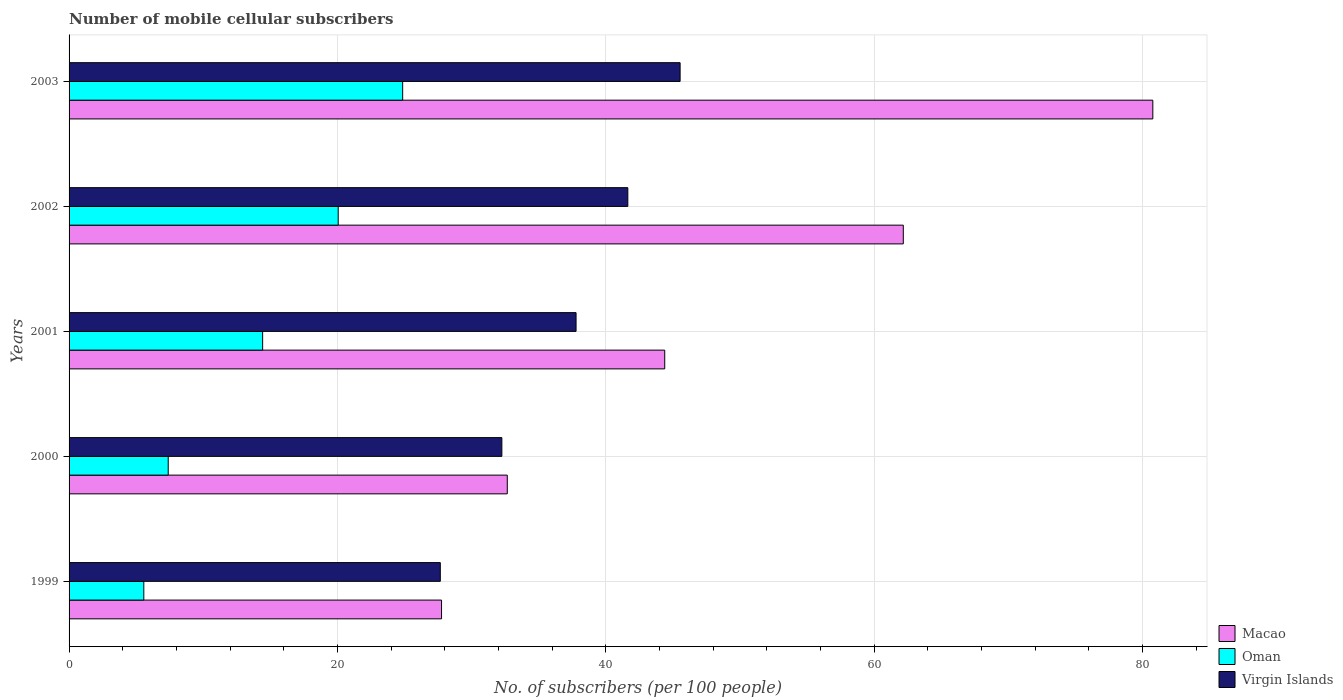Are the number of bars on each tick of the Y-axis equal?
Offer a terse response. Yes. How many bars are there on the 1st tick from the top?
Provide a succinct answer. 3. In how many cases, is the number of bars for a given year not equal to the number of legend labels?
Ensure brevity in your answer.  0. What is the number of mobile cellular subscribers in Virgin Islands in 2001?
Provide a succinct answer. 37.78. Across all years, what is the maximum number of mobile cellular subscribers in Oman?
Your answer should be compact. 24.86. Across all years, what is the minimum number of mobile cellular subscribers in Virgin Islands?
Your answer should be very brief. 27.67. In which year was the number of mobile cellular subscribers in Macao minimum?
Your answer should be compact. 1999. What is the total number of mobile cellular subscribers in Oman in the graph?
Provide a succinct answer. 72.3. What is the difference between the number of mobile cellular subscribers in Oman in 1999 and that in 2003?
Make the answer very short. -19.29. What is the difference between the number of mobile cellular subscribers in Macao in 1999 and the number of mobile cellular subscribers in Oman in 2003?
Offer a very short reply. 2.9. What is the average number of mobile cellular subscribers in Virgin Islands per year?
Keep it short and to the point. 36.98. In the year 2003, what is the difference between the number of mobile cellular subscribers in Virgin Islands and number of mobile cellular subscribers in Macao?
Provide a short and direct response. -35.23. In how many years, is the number of mobile cellular subscribers in Virgin Islands greater than 72 ?
Make the answer very short. 0. What is the ratio of the number of mobile cellular subscribers in Macao in 2001 to that in 2002?
Keep it short and to the point. 0.71. Is the difference between the number of mobile cellular subscribers in Virgin Islands in 1999 and 2003 greater than the difference between the number of mobile cellular subscribers in Macao in 1999 and 2003?
Your answer should be compact. Yes. What is the difference between the highest and the second highest number of mobile cellular subscribers in Oman?
Your response must be concise. 4.81. What is the difference between the highest and the lowest number of mobile cellular subscribers in Oman?
Provide a succinct answer. 19.29. What does the 1st bar from the top in 2002 represents?
Offer a terse response. Virgin Islands. What does the 2nd bar from the bottom in 2000 represents?
Offer a very short reply. Oman. Is it the case that in every year, the sum of the number of mobile cellular subscribers in Oman and number of mobile cellular subscribers in Virgin Islands is greater than the number of mobile cellular subscribers in Macao?
Ensure brevity in your answer.  No. Are all the bars in the graph horizontal?
Make the answer very short. Yes. How many years are there in the graph?
Provide a short and direct response. 5. What is the difference between two consecutive major ticks on the X-axis?
Your response must be concise. 20. Does the graph contain any zero values?
Keep it short and to the point. No. Where does the legend appear in the graph?
Provide a short and direct response. Bottom right. How are the legend labels stacked?
Make the answer very short. Vertical. What is the title of the graph?
Offer a terse response. Number of mobile cellular subscribers. Does "Israel" appear as one of the legend labels in the graph?
Provide a succinct answer. No. What is the label or title of the X-axis?
Make the answer very short. No. of subscribers (per 100 people). What is the label or title of the Y-axis?
Keep it short and to the point. Years. What is the No. of subscribers (per 100 people) of Macao in 1999?
Ensure brevity in your answer.  27.76. What is the No. of subscribers (per 100 people) in Oman in 1999?
Provide a short and direct response. 5.57. What is the No. of subscribers (per 100 people) in Virgin Islands in 1999?
Offer a terse response. 27.67. What is the No. of subscribers (per 100 people) of Macao in 2000?
Keep it short and to the point. 32.66. What is the No. of subscribers (per 100 people) in Oman in 2000?
Give a very brief answer. 7.39. What is the No. of subscribers (per 100 people) of Virgin Islands in 2000?
Offer a terse response. 32.25. What is the No. of subscribers (per 100 people) in Macao in 2001?
Offer a terse response. 44.39. What is the No. of subscribers (per 100 people) of Oman in 2001?
Offer a terse response. 14.43. What is the No. of subscribers (per 100 people) in Virgin Islands in 2001?
Your answer should be compact. 37.78. What is the No. of subscribers (per 100 people) in Macao in 2002?
Make the answer very short. 62.17. What is the No. of subscribers (per 100 people) of Oman in 2002?
Give a very brief answer. 20.06. What is the No. of subscribers (per 100 people) in Virgin Islands in 2002?
Offer a very short reply. 41.64. What is the No. of subscribers (per 100 people) in Macao in 2003?
Provide a short and direct response. 80.77. What is the No. of subscribers (per 100 people) in Oman in 2003?
Ensure brevity in your answer.  24.86. What is the No. of subscribers (per 100 people) in Virgin Islands in 2003?
Make the answer very short. 45.54. Across all years, what is the maximum No. of subscribers (per 100 people) of Macao?
Offer a very short reply. 80.77. Across all years, what is the maximum No. of subscribers (per 100 people) of Oman?
Your answer should be very brief. 24.86. Across all years, what is the maximum No. of subscribers (per 100 people) of Virgin Islands?
Provide a succinct answer. 45.54. Across all years, what is the minimum No. of subscribers (per 100 people) of Macao?
Make the answer very short. 27.76. Across all years, what is the minimum No. of subscribers (per 100 people) in Oman?
Offer a terse response. 5.57. Across all years, what is the minimum No. of subscribers (per 100 people) of Virgin Islands?
Keep it short and to the point. 27.67. What is the total No. of subscribers (per 100 people) in Macao in the graph?
Your answer should be compact. 247.75. What is the total No. of subscribers (per 100 people) of Oman in the graph?
Provide a short and direct response. 72.3. What is the total No. of subscribers (per 100 people) of Virgin Islands in the graph?
Ensure brevity in your answer.  184.89. What is the difference between the No. of subscribers (per 100 people) in Macao in 1999 and that in 2000?
Your response must be concise. -4.9. What is the difference between the No. of subscribers (per 100 people) of Oman in 1999 and that in 2000?
Keep it short and to the point. -1.82. What is the difference between the No. of subscribers (per 100 people) of Virgin Islands in 1999 and that in 2000?
Keep it short and to the point. -4.59. What is the difference between the No. of subscribers (per 100 people) of Macao in 1999 and that in 2001?
Keep it short and to the point. -16.63. What is the difference between the No. of subscribers (per 100 people) in Oman in 1999 and that in 2001?
Offer a very short reply. -8.86. What is the difference between the No. of subscribers (per 100 people) of Virgin Islands in 1999 and that in 2001?
Your response must be concise. -10.12. What is the difference between the No. of subscribers (per 100 people) of Macao in 1999 and that in 2002?
Give a very brief answer. -34.41. What is the difference between the No. of subscribers (per 100 people) of Oman in 1999 and that in 2002?
Provide a succinct answer. -14.49. What is the difference between the No. of subscribers (per 100 people) of Virgin Islands in 1999 and that in 2002?
Your answer should be very brief. -13.98. What is the difference between the No. of subscribers (per 100 people) in Macao in 1999 and that in 2003?
Provide a succinct answer. -53.01. What is the difference between the No. of subscribers (per 100 people) in Oman in 1999 and that in 2003?
Your response must be concise. -19.29. What is the difference between the No. of subscribers (per 100 people) in Virgin Islands in 1999 and that in 2003?
Offer a very short reply. -17.87. What is the difference between the No. of subscribers (per 100 people) in Macao in 2000 and that in 2001?
Make the answer very short. -11.73. What is the difference between the No. of subscribers (per 100 people) in Oman in 2000 and that in 2001?
Offer a very short reply. -7.04. What is the difference between the No. of subscribers (per 100 people) of Virgin Islands in 2000 and that in 2001?
Keep it short and to the point. -5.53. What is the difference between the No. of subscribers (per 100 people) in Macao in 2000 and that in 2002?
Provide a short and direct response. -29.51. What is the difference between the No. of subscribers (per 100 people) in Oman in 2000 and that in 2002?
Ensure brevity in your answer.  -12.67. What is the difference between the No. of subscribers (per 100 people) in Virgin Islands in 2000 and that in 2002?
Provide a short and direct response. -9.39. What is the difference between the No. of subscribers (per 100 people) in Macao in 2000 and that in 2003?
Offer a terse response. -48.11. What is the difference between the No. of subscribers (per 100 people) of Oman in 2000 and that in 2003?
Provide a short and direct response. -17.47. What is the difference between the No. of subscribers (per 100 people) of Virgin Islands in 2000 and that in 2003?
Your answer should be very brief. -13.28. What is the difference between the No. of subscribers (per 100 people) of Macao in 2001 and that in 2002?
Provide a succinct answer. -17.78. What is the difference between the No. of subscribers (per 100 people) in Oman in 2001 and that in 2002?
Offer a very short reply. -5.63. What is the difference between the No. of subscribers (per 100 people) of Virgin Islands in 2001 and that in 2002?
Make the answer very short. -3.86. What is the difference between the No. of subscribers (per 100 people) of Macao in 2001 and that in 2003?
Make the answer very short. -36.38. What is the difference between the No. of subscribers (per 100 people) in Oman in 2001 and that in 2003?
Keep it short and to the point. -10.44. What is the difference between the No. of subscribers (per 100 people) in Virgin Islands in 2001 and that in 2003?
Ensure brevity in your answer.  -7.75. What is the difference between the No. of subscribers (per 100 people) of Macao in 2002 and that in 2003?
Ensure brevity in your answer.  -18.6. What is the difference between the No. of subscribers (per 100 people) of Oman in 2002 and that in 2003?
Offer a very short reply. -4.81. What is the difference between the No. of subscribers (per 100 people) of Virgin Islands in 2002 and that in 2003?
Give a very brief answer. -3.9. What is the difference between the No. of subscribers (per 100 people) of Macao in 1999 and the No. of subscribers (per 100 people) of Oman in 2000?
Offer a very short reply. 20.37. What is the difference between the No. of subscribers (per 100 people) of Macao in 1999 and the No. of subscribers (per 100 people) of Virgin Islands in 2000?
Offer a very short reply. -4.5. What is the difference between the No. of subscribers (per 100 people) of Oman in 1999 and the No. of subscribers (per 100 people) of Virgin Islands in 2000?
Provide a succinct answer. -26.68. What is the difference between the No. of subscribers (per 100 people) of Macao in 1999 and the No. of subscribers (per 100 people) of Oman in 2001?
Give a very brief answer. 13.33. What is the difference between the No. of subscribers (per 100 people) in Macao in 1999 and the No. of subscribers (per 100 people) in Virgin Islands in 2001?
Your answer should be very brief. -10.03. What is the difference between the No. of subscribers (per 100 people) of Oman in 1999 and the No. of subscribers (per 100 people) of Virgin Islands in 2001?
Offer a very short reply. -32.21. What is the difference between the No. of subscribers (per 100 people) of Macao in 1999 and the No. of subscribers (per 100 people) of Oman in 2002?
Give a very brief answer. 7.7. What is the difference between the No. of subscribers (per 100 people) in Macao in 1999 and the No. of subscribers (per 100 people) in Virgin Islands in 2002?
Give a very brief answer. -13.88. What is the difference between the No. of subscribers (per 100 people) in Oman in 1999 and the No. of subscribers (per 100 people) in Virgin Islands in 2002?
Ensure brevity in your answer.  -36.07. What is the difference between the No. of subscribers (per 100 people) in Macao in 1999 and the No. of subscribers (per 100 people) in Oman in 2003?
Offer a very short reply. 2.9. What is the difference between the No. of subscribers (per 100 people) of Macao in 1999 and the No. of subscribers (per 100 people) of Virgin Islands in 2003?
Keep it short and to the point. -17.78. What is the difference between the No. of subscribers (per 100 people) in Oman in 1999 and the No. of subscribers (per 100 people) in Virgin Islands in 2003?
Provide a short and direct response. -39.97. What is the difference between the No. of subscribers (per 100 people) of Macao in 2000 and the No. of subscribers (per 100 people) of Oman in 2001?
Make the answer very short. 18.23. What is the difference between the No. of subscribers (per 100 people) in Macao in 2000 and the No. of subscribers (per 100 people) in Virgin Islands in 2001?
Your response must be concise. -5.13. What is the difference between the No. of subscribers (per 100 people) in Oman in 2000 and the No. of subscribers (per 100 people) in Virgin Islands in 2001?
Your answer should be compact. -30.4. What is the difference between the No. of subscribers (per 100 people) in Macao in 2000 and the No. of subscribers (per 100 people) in Oman in 2002?
Provide a short and direct response. 12.6. What is the difference between the No. of subscribers (per 100 people) in Macao in 2000 and the No. of subscribers (per 100 people) in Virgin Islands in 2002?
Give a very brief answer. -8.98. What is the difference between the No. of subscribers (per 100 people) of Oman in 2000 and the No. of subscribers (per 100 people) of Virgin Islands in 2002?
Your response must be concise. -34.25. What is the difference between the No. of subscribers (per 100 people) in Macao in 2000 and the No. of subscribers (per 100 people) in Oman in 2003?
Keep it short and to the point. 7.8. What is the difference between the No. of subscribers (per 100 people) of Macao in 2000 and the No. of subscribers (per 100 people) of Virgin Islands in 2003?
Give a very brief answer. -12.88. What is the difference between the No. of subscribers (per 100 people) of Oman in 2000 and the No. of subscribers (per 100 people) of Virgin Islands in 2003?
Your answer should be very brief. -38.15. What is the difference between the No. of subscribers (per 100 people) in Macao in 2001 and the No. of subscribers (per 100 people) in Oman in 2002?
Keep it short and to the point. 24.34. What is the difference between the No. of subscribers (per 100 people) of Macao in 2001 and the No. of subscribers (per 100 people) of Virgin Islands in 2002?
Offer a very short reply. 2.75. What is the difference between the No. of subscribers (per 100 people) of Oman in 2001 and the No. of subscribers (per 100 people) of Virgin Islands in 2002?
Your response must be concise. -27.22. What is the difference between the No. of subscribers (per 100 people) of Macao in 2001 and the No. of subscribers (per 100 people) of Oman in 2003?
Ensure brevity in your answer.  19.53. What is the difference between the No. of subscribers (per 100 people) of Macao in 2001 and the No. of subscribers (per 100 people) of Virgin Islands in 2003?
Keep it short and to the point. -1.15. What is the difference between the No. of subscribers (per 100 people) in Oman in 2001 and the No. of subscribers (per 100 people) in Virgin Islands in 2003?
Make the answer very short. -31.11. What is the difference between the No. of subscribers (per 100 people) of Macao in 2002 and the No. of subscribers (per 100 people) of Oman in 2003?
Your answer should be very brief. 37.31. What is the difference between the No. of subscribers (per 100 people) in Macao in 2002 and the No. of subscribers (per 100 people) in Virgin Islands in 2003?
Give a very brief answer. 16.63. What is the difference between the No. of subscribers (per 100 people) in Oman in 2002 and the No. of subscribers (per 100 people) in Virgin Islands in 2003?
Your response must be concise. -25.48. What is the average No. of subscribers (per 100 people) of Macao per year?
Your response must be concise. 49.55. What is the average No. of subscribers (per 100 people) of Oman per year?
Offer a terse response. 14.46. What is the average No. of subscribers (per 100 people) in Virgin Islands per year?
Provide a succinct answer. 36.98. In the year 1999, what is the difference between the No. of subscribers (per 100 people) in Macao and No. of subscribers (per 100 people) in Oman?
Your answer should be compact. 22.19. In the year 1999, what is the difference between the No. of subscribers (per 100 people) in Macao and No. of subscribers (per 100 people) in Virgin Islands?
Ensure brevity in your answer.  0.09. In the year 1999, what is the difference between the No. of subscribers (per 100 people) in Oman and No. of subscribers (per 100 people) in Virgin Islands?
Your answer should be very brief. -22.1. In the year 2000, what is the difference between the No. of subscribers (per 100 people) of Macao and No. of subscribers (per 100 people) of Oman?
Your answer should be very brief. 25.27. In the year 2000, what is the difference between the No. of subscribers (per 100 people) in Macao and No. of subscribers (per 100 people) in Virgin Islands?
Provide a succinct answer. 0.4. In the year 2000, what is the difference between the No. of subscribers (per 100 people) of Oman and No. of subscribers (per 100 people) of Virgin Islands?
Make the answer very short. -24.87. In the year 2001, what is the difference between the No. of subscribers (per 100 people) in Macao and No. of subscribers (per 100 people) in Oman?
Make the answer very short. 29.97. In the year 2001, what is the difference between the No. of subscribers (per 100 people) of Macao and No. of subscribers (per 100 people) of Virgin Islands?
Give a very brief answer. 6.61. In the year 2001, what is the difference between the No. of subscribers (per 100 people) of Oman and No. of subscribers (per 100 people) of Virgin Islands?
Provide a short and direct response. -23.36. In the year 2002, what is the difference between the No. of subscribers (per 100 people) in Macao and No. of subscribers (per 100 people) in Oman?
Make the answer very short. 42.12. In the year 2002, what is the difference between the No. of subscribers (per 100 people) in Macao and No. of subscribers (per 100 people) in Virgin Islands?
Provide a short and direct response. 20.53. In the year 2002, what is the difference between the No. of subscribers (per 100 people) of Oman and No. of subscribers (per 100 people) of Virgin Islands?
Ensure brevity in your answer.  -21.59. In the year 2003, what is the difference between the No. of subscribers (per 100 people) of Macao and No. of subscribers (per 100 people) of Oman?
Provide a succinct answer. 55.91. In the year 2003, what is the difference between the No. of subscribers (per 100 people) in Macao and No. of subscribers (per 100 people) in Virgin Islands?
Ensure brevity in your answer.  35.23. In the year 2003, what is the difference between the No. of subscribers (per 100 people) of Oman and No. of subscribers (per 100 people) of Virgin Islands?
Offer a very short reply. -20.68. What is the ratio of the No. of subscribers (per 100 people) in Oman in 1999 to that in 2000?
Provide a succinct answer. 0.75. What is the ratio of the No. of subscribers (per 100 people) of Virgin Islands in 1999 to that in 2000?
Keep it short and to the point. 0.86. What is the ratio of the No. of subscribers (per 100 people) in Macao in 1999 to that in 2001?
Your answer should be very brief. 0.63. What is the ratio of the No. of subscribers (per 100 people) of Oman in 1999 to that in 2001?
Your response must be concise. 0.39. What is the ratio of the No. of subscribers (per 100 people) of Virgin Islands in 1999 to that in 2001?
Offer a terse response. 0.73. What is the ratio of the No. of subscribers (per 100 people) in Macao in 1999 to that in 2002?
Keep it short and to the point. 0.45. What is the ratio of the No. of subscribers (per 100 people) of Oman in 1999 to that in 2002?
Give a very brief answer. 0.28. What is the ratio of the No. of subscribers (per 100 people) of Virgin Islands in 1999 to that in 2002?
Provide a succinct answer. 0.66. What is the ratio of the No. of subscribers (per 100 people) of Macao in 1999 to that in 2003?
Your answer should be compact. 0.34. What is the ratio of the No. of subscribers (per 100 people) of Oman in 1999 to that in 2003?
Offer a terse response. 0.22. What is the ratio of the No. of subscribers (per 100 people) of Virgin Islands in 1999 to that in 2003?
Offer a very short reply. 0.61. What is the ratio of the No. of subscribers (per 100 people) in Macao in 2000 to that in 2001?
Your answer should be very brief. 0.74. What is the ratio of the No. of subscribers (per 100 people) of Oman in 2000 to that in 2001?
Make the answer very short. 0.51. What is the ratio of the No. of subscribers (per 100 people) of Virgin Islands in 2000 to that in 2001?
Provide a succinct answer. 0.85. What is the ratio of the No. of subscribers (per 100 people) in Macao in 2000 to that in 2002?
Your answer should be compact. 0.53. What is the ratio of the No. of subscribers (per 100 people) in Oman in 2000 to that in 2002?
Provide a short and direct response. 0.37. What is the ratio of the No. of subscribers (per 100 people) in Virgin Islands in 2000 to that in 2002?
Ensure brevity in your answer.  0.77. What is the ratio of the No. of subscribers (per 100 people) of Macao in 2000 to that in 2003?
Make the answer very short. 0.4. What is the ratio of the No. of subscribers (per 100 people) of Oman in 2000 to that in 2003?
Provide a succinct answer. 0.3. What is the ratio of the No. of subscribers (per 100 people) in Virgin Islands in 2000 to that in 2003?
Provide a short and direct response. 0.71. What is the ratio of the No. of subscribers (per 100 people) of Macao in 2001 to that in 2002?
Provide a short and direct response. 0.71. What is the ratio of the No. of subscribers (per 100 people) of Oman in 2001 to that in 2002?
Your answer should be very brief. 0.72. What is the ratio of the No. of subscribers (per 100 people) in Virgin Islands in 2001 to that in 2002?
Ensure brevity in your answer.  0.91. What is the ratio of the No. of subscribers (per 100 people) in Macao in 2001 to that in 2003?
Ensure brevity in your answer.  0.55. What is the ratio of the No. of subscribers (per 100 people) in Oman in 2001 to that in 2003?
Provide a short and direct response. 0.58. What is the ratio of the No. of subscribers (per 100 people) in Virgin Islands in 2001 to that in 2003?
Give a very brief answer. 0.83. What is the ratio of the No. of subscribers (per 100 people) in Macao in 2002 to that in 2003?
Your answer should be compact. 0.77. What is the ratio of the No. of subscribers (per 100 people) in Oman in 2002 to that in 2003?
Ensure brevity in your answer.  0.81. What is the ratio of the No. of subscribers (per 100 people) in Virgin Islands in 2002 to that in 2003?
Provide a succinct answer. 0.91. What is the difference between the highest and the second highest No. of subscribers (per 100 people) of Macao?
Your answer should be compact. 18.6. What is the difference between the highest and the second highest No. of subscribers (per 100 people) in Oman?
Offer a terse response. 4.81. What is the difference between the highest and the second highest No. of subscribers (per 100 people) in Virgin Islands?
Ensure brevity in your answer.  3.9. What is the difference between the highest and the lowest No. of subscribers (per 100 people) in Macao?
Offer a very short reply. 53.01. What is the difference between the highest and the lowest No. of subscribers (per 100 people) of Oman?
Make the answer very short. 19.29. What is the difference between the highest and the lowest No. of subscribers (per 100 people) of Virgin Islands?
Provide a short and direct response. 17.87. 